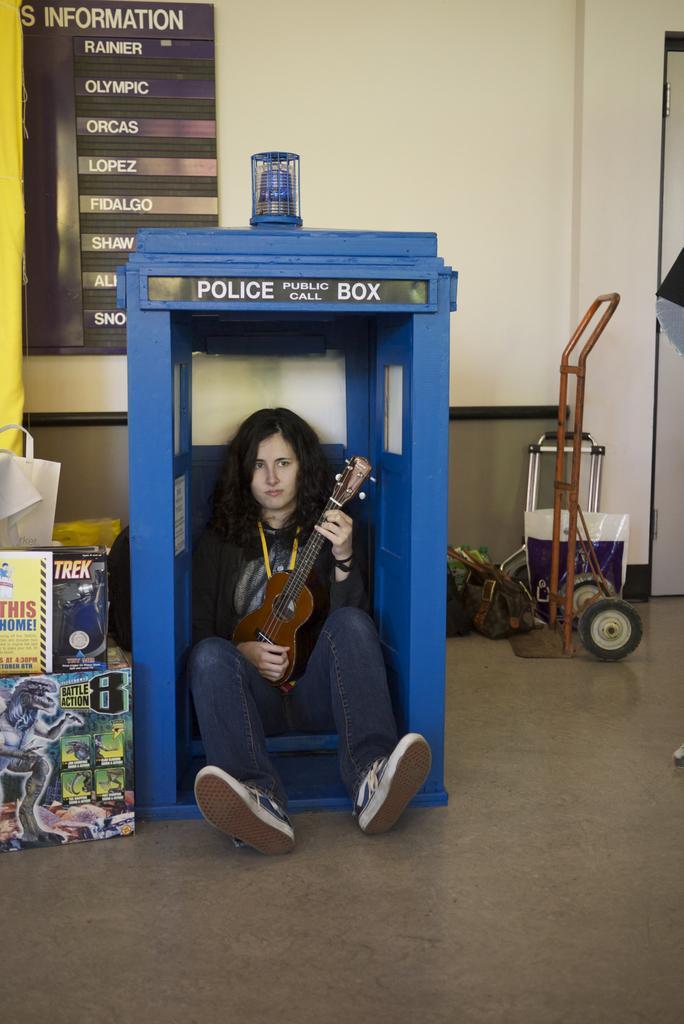Please provide a concise description of this image. A woman holding a small guitar is sitting inside a blue box. Beside her there is another boxes. In the right side there is a packet, some other items. In the background there is a wall and a notice. 